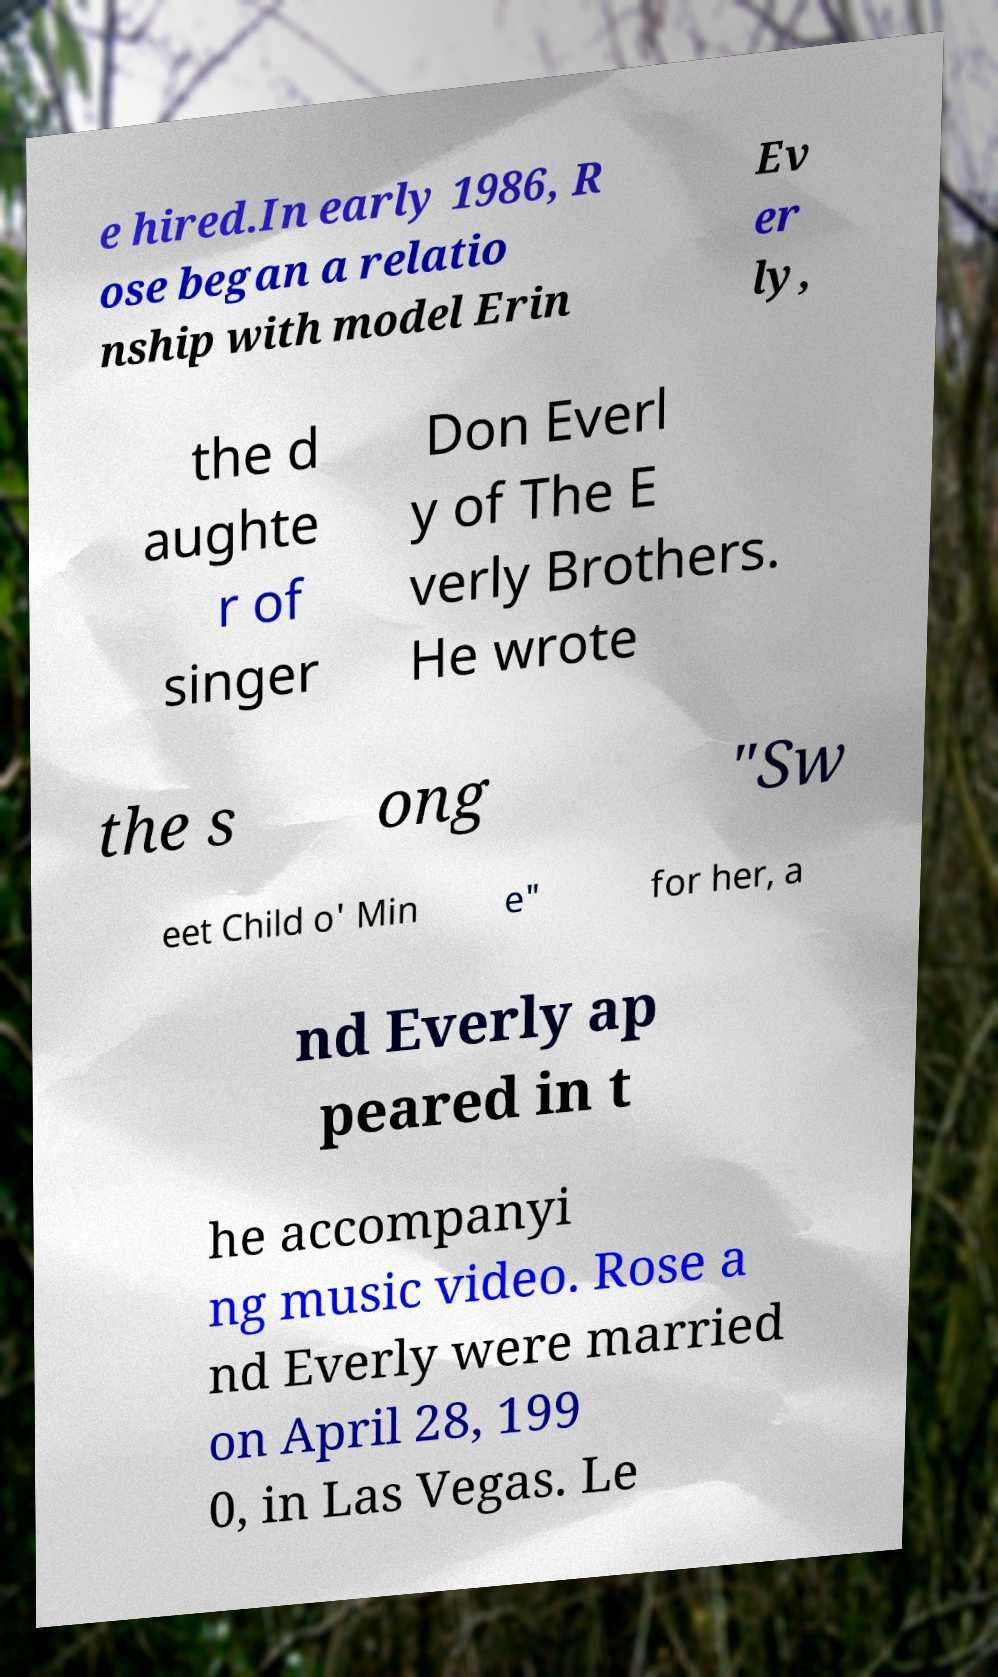What messages or text are displayed in this image? I need them in a readable, typed format. e hired.In early 1986, R ose began a relatio nship with model Erin Ev er ly, the d aughte r of singer Don Everl y of The E verly Brothers. He wrote the s ong "Sw eet Child o' Min e" for her, a nd Everly ap peared in t he accompanyi ng music video. Rose a nd Everly were married on April 28, 199 0, in Las Vegas. Le 